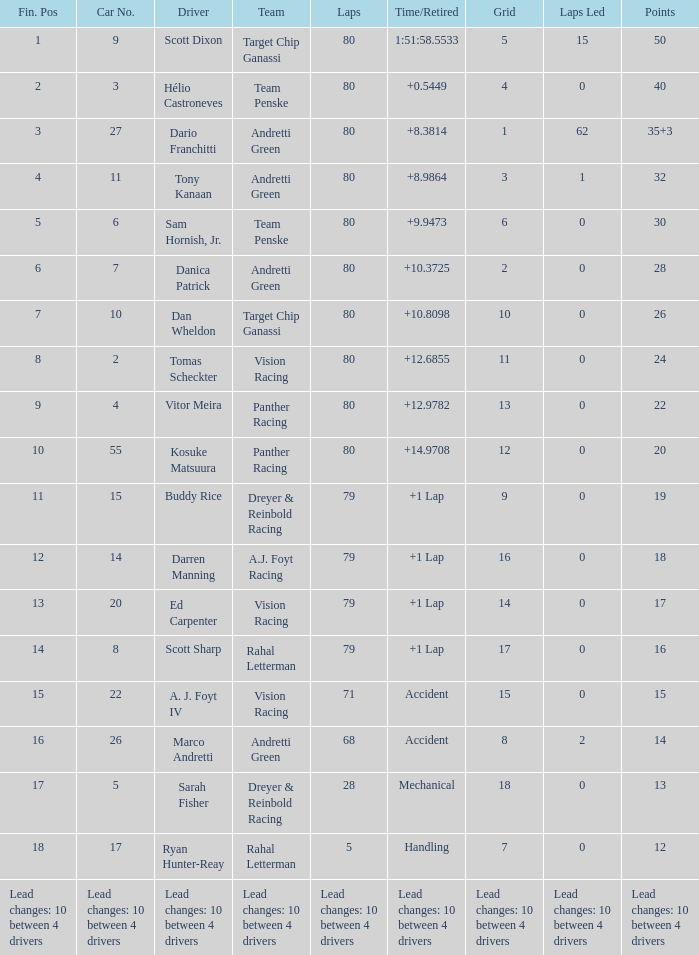In which grid can you find 24 points? 11.0. 